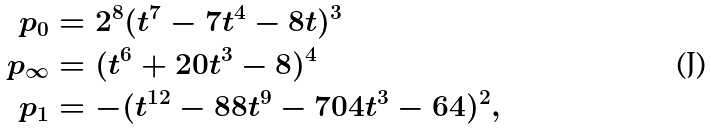Convert formula to latex. <formula><loc_0><loc_0><loc_500><loc_500>p _ { 0 } & = 2 ^ { 8 } ( t ^ { 7 } - 7 t ^ { 4 } - 8 t ) ^ { 3 } \\ p _ { \infty } & = ( t ^ { 6 } + 2 0 t ^ { 3 } - 8 ) ^ { 4 } \\ p _ { 1 } & = - ( t ^ { 1 2 } - 8 8 t ^ { 9 } - 7 0 4 t ^ { 3 } - 6 4 ) ^ { 2 } ,</formula> 